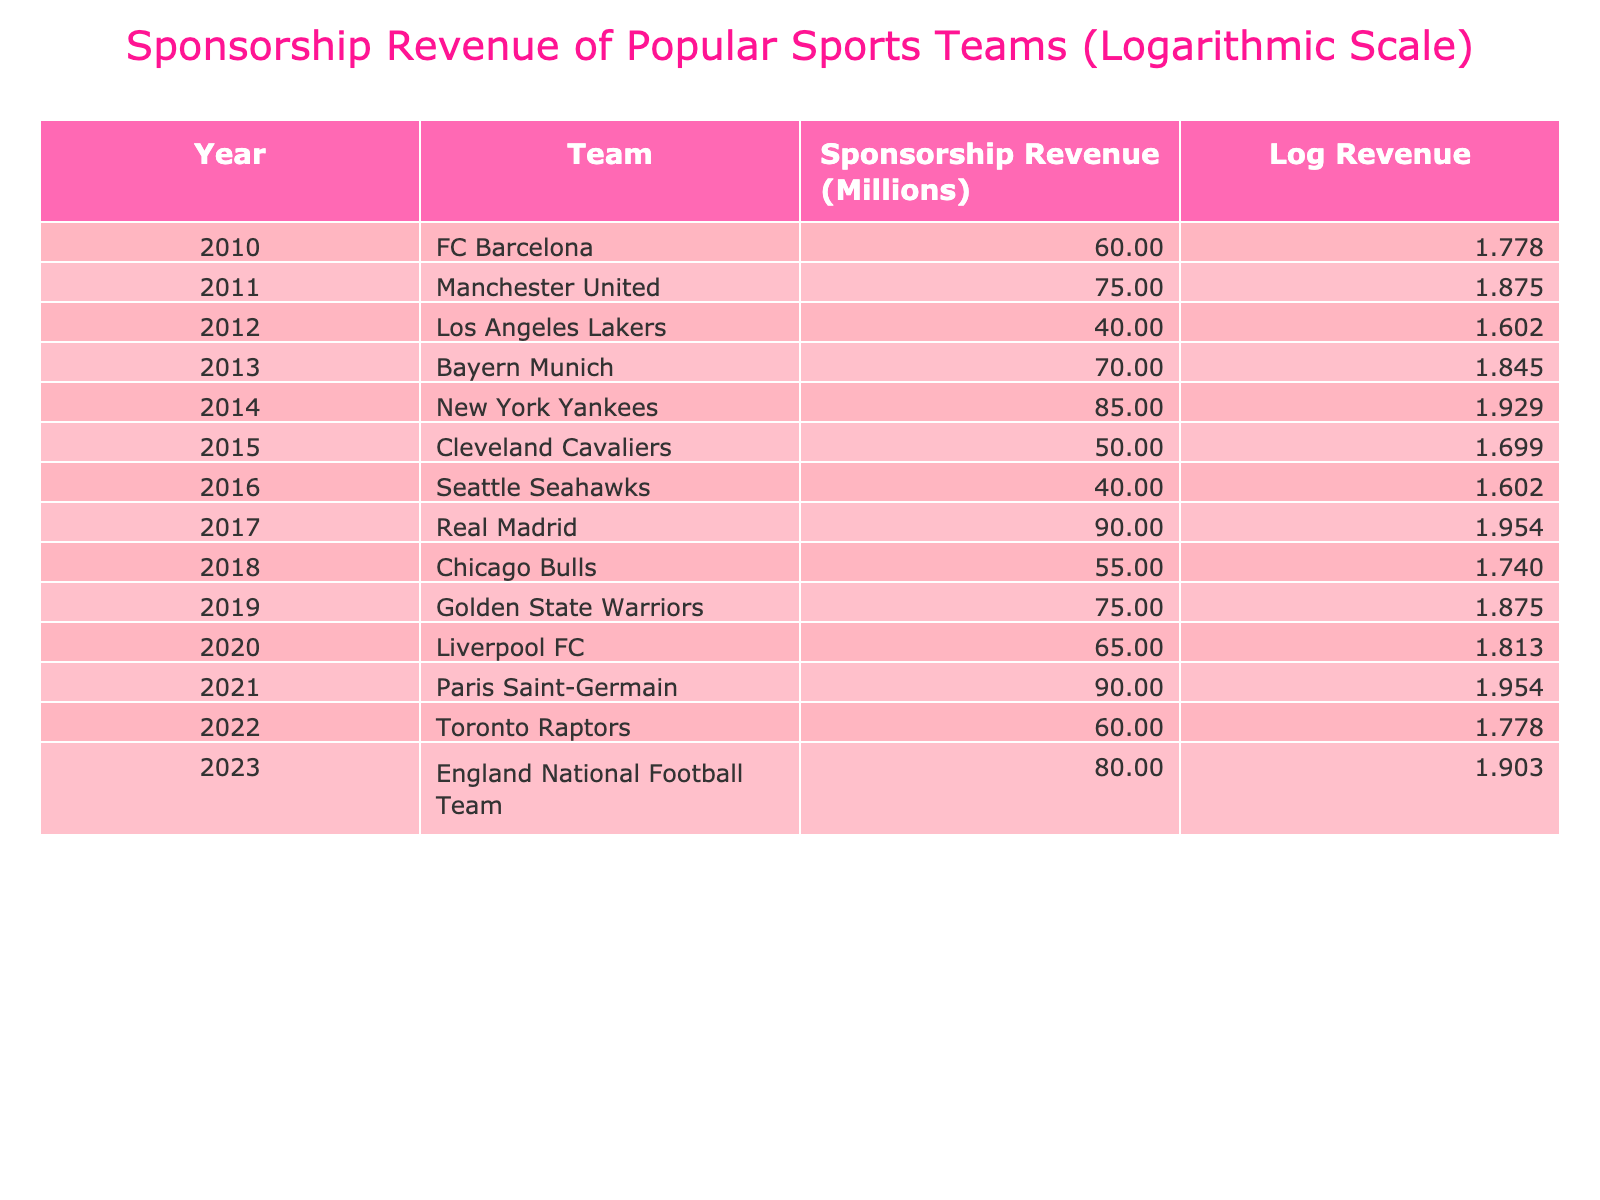What was the sponsorship revenue for FC Barcelona in 2010? According to the table, the sponsorship revenue for FC Barcelona in 2010 is listed directly in the row corresponding to that team and year as 60 million.
Answer: 60 million Which team had the highest sponsorship revenue in 2014? In 2014, the team with the highest sponsorship revenue listed in the table is the New York Yankees with 85 million.
Answer: New York Yankees What is the average sponsorship revenue from 2010 to 2023? To calculate the average, sum all the sponsorship revenues from 2010 to 2023: (60 + 75 + 40 + 70 + 85 + 50 + 40 + 90 + 55 + 75 + 65 + 90 + 60 + 80) = 1010 million. There are 14 data points; therefore, the average is 1010/14 = approximately 72.14 million.
Answer: Approximately 72.14 million Did the Cleveland Cavaliers generate more sponsorship revenue than the Seattle Seahawks in 2016? In 2016, the Cleveland Cavaliers' sponsorship revenue is 50 million, while the Seattle Seahawks generated 40 million. Since 50 is greater than 40, the statement is true.
Answer: Yes Which team's sponsorship revenue grew the most from 2017 to 2021? In 2017, Real Madrid had a revenue of 90 million, and in 2021, Paris Saint-Germain also had a revenue of 90 million, indicating no growth for Real Madrid. Considering all other teams, looking closely at the revenues for 2017 (90 million) and 2021 (90 million) shows no team grew more than the difference of (90 - 65) = 25 million for Liverpool FC from 2019 to 2020. Therefore, Liverpool FC had the highest growth from 2017 to 2021, as others had similar revenue levels.
Answer: Liverpool FC How many teams generated more than 70 million in sponsorship revenue in 2022? The 2022 column shows that only the teams with revenues 80 million (England National Football Team) and 90 million (Paris Saint-Germain), totaling two teams with revenues exceeding 70 million.
Answer: 2 